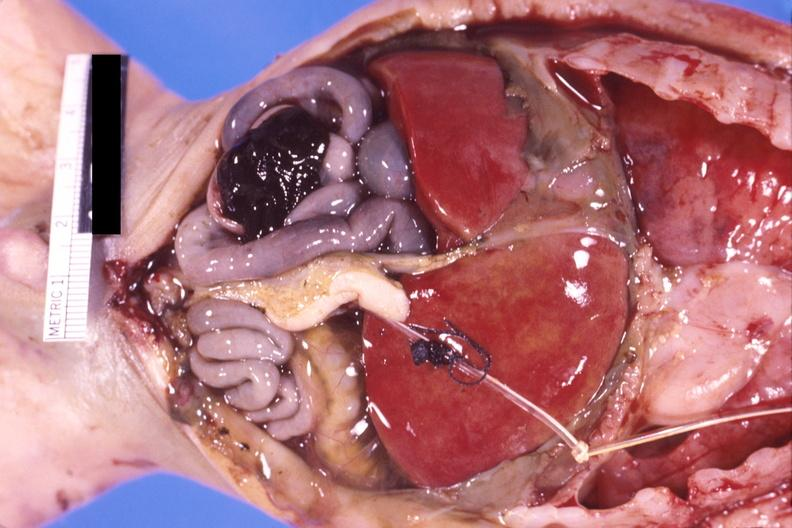does peritoneal fluid show pneumotosis intestinalis with rupture and hemorrhage in a patient with hyaline membrane disease?
Answer the question using a single word or phrase. No 